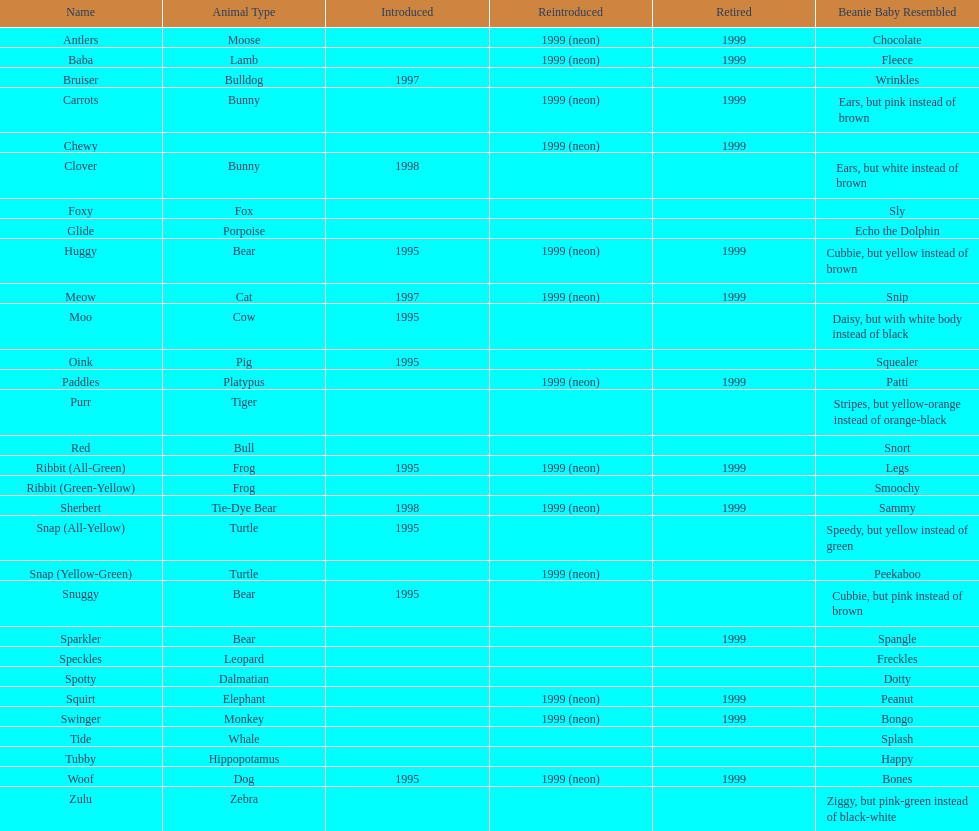Which of the enumerated pillow pals have inadequate information in not less than 3 categories? Chewy, Foxy, Glide, Purr, Red, Ribbit (Green-Yellow), Speckles, Spotty, Tide, Tubby, Zulu. Out of those, which one is lacking details in the animal variety category? Chewy. 